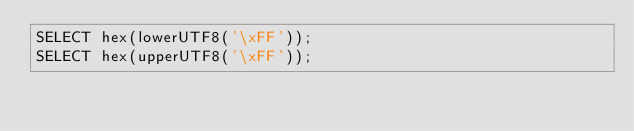Convert code to text. <code><loc_0><loc_0><loc_500><loc_500><_SQL_>SELECT hex(lowerUTF8('\xFF'));
SELECT hex(upperUTF8('\xFF'));
</code> 